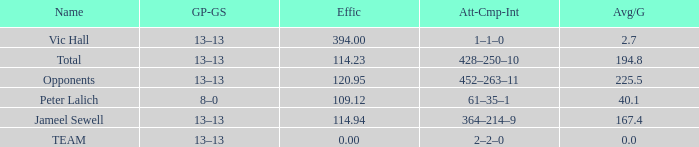Avg/G that has a GP-GS of 13–13, and a Effic smaller than 114.23 has what total of numbers? 1.0. Write the full table. {'header': ['Name', 'GP-GS', 'Effic', 'Att-Cmp-Int', 'Avg/G'], 'rows': [['Vic Hall', '13–13', '394.00', '1–1–0', '2.7'], ['Total', '13–13', '114.23', '428–250–10', '194.8'], ['Opponents', '13–13', '120.95', '452–263–11', '225.5'], ['Peter Lalich', '8–0', '109.12', '61–35–1', '40.1'], ['Jameel Sewell', '13–13', '114.94', '364–214–9', '167.4'], ['TEAM', '13–13', '0.00', '2–2–0', '0.0']]} 